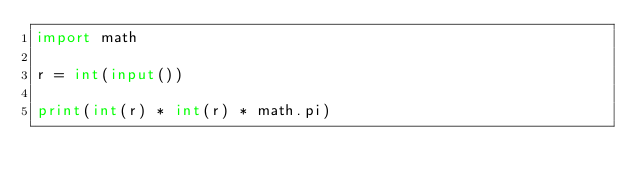<code> <loc_0><loc_0><loc_500><loc_500><_Python_>import math

r = int(input())

print(int(r) * int(r) * math.pi)
</code> 